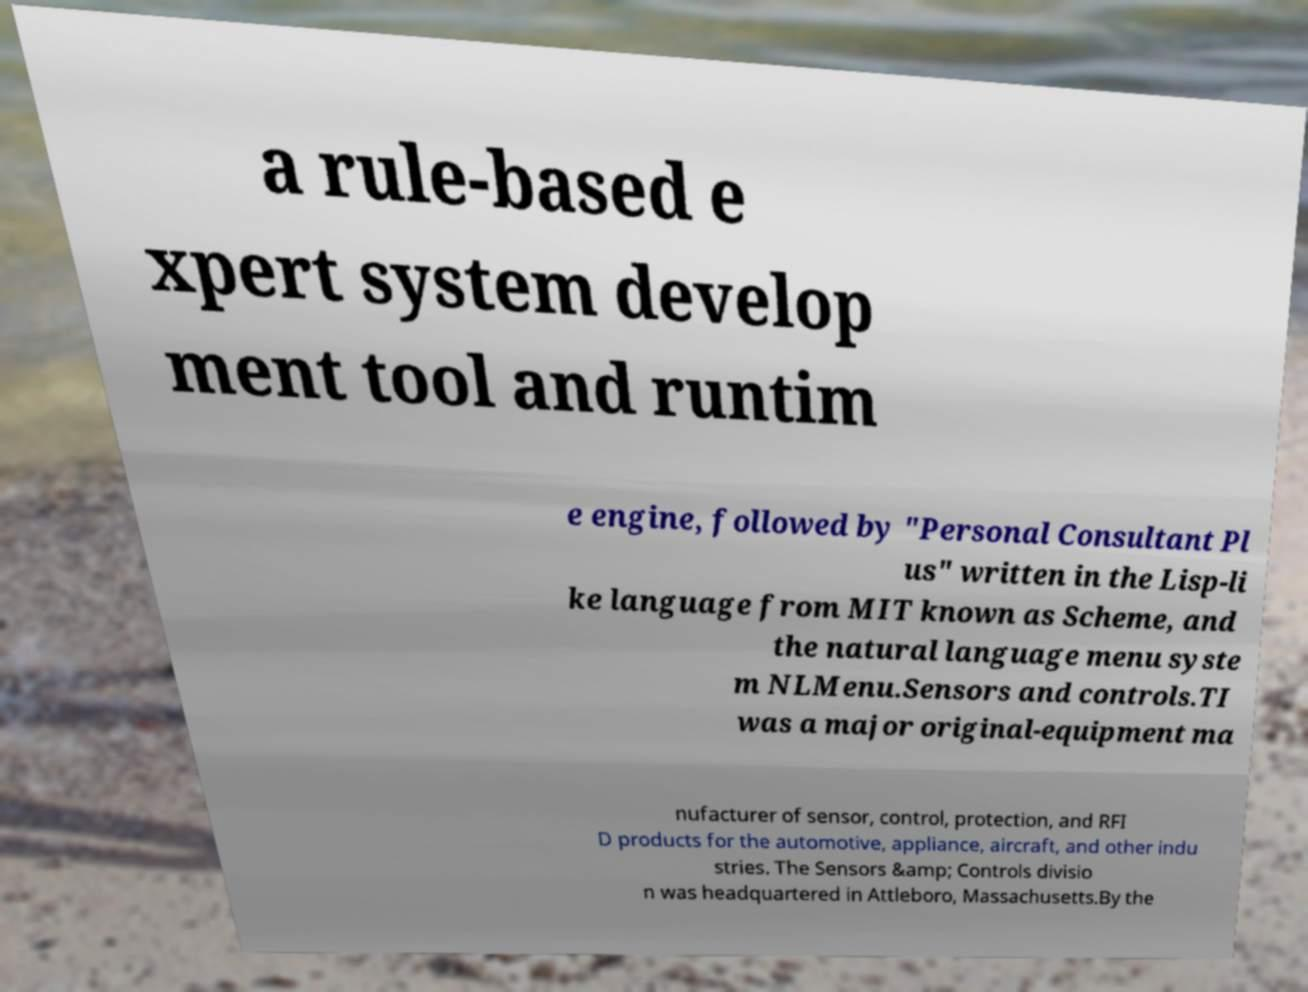For documentation purposes, I need the text within this image transcribed. Could you provide that? a rule-based e xpert system develop ment tool and runtim e engine, followed by "Personal Consultant Pl us" written in the Lisp-li ke language from MIT known as Scheme, and the natural language menu syste m NLMenu.Sensors and controls.TI was a major original-equipment ma nufacturer of sensor, control, protection, and RFI D products for the automotive, appliance, aircraft, and other indu stries. The Sensors &amp; Controls divisio n was headquartered in Attleboro, Massachusetts.By the 